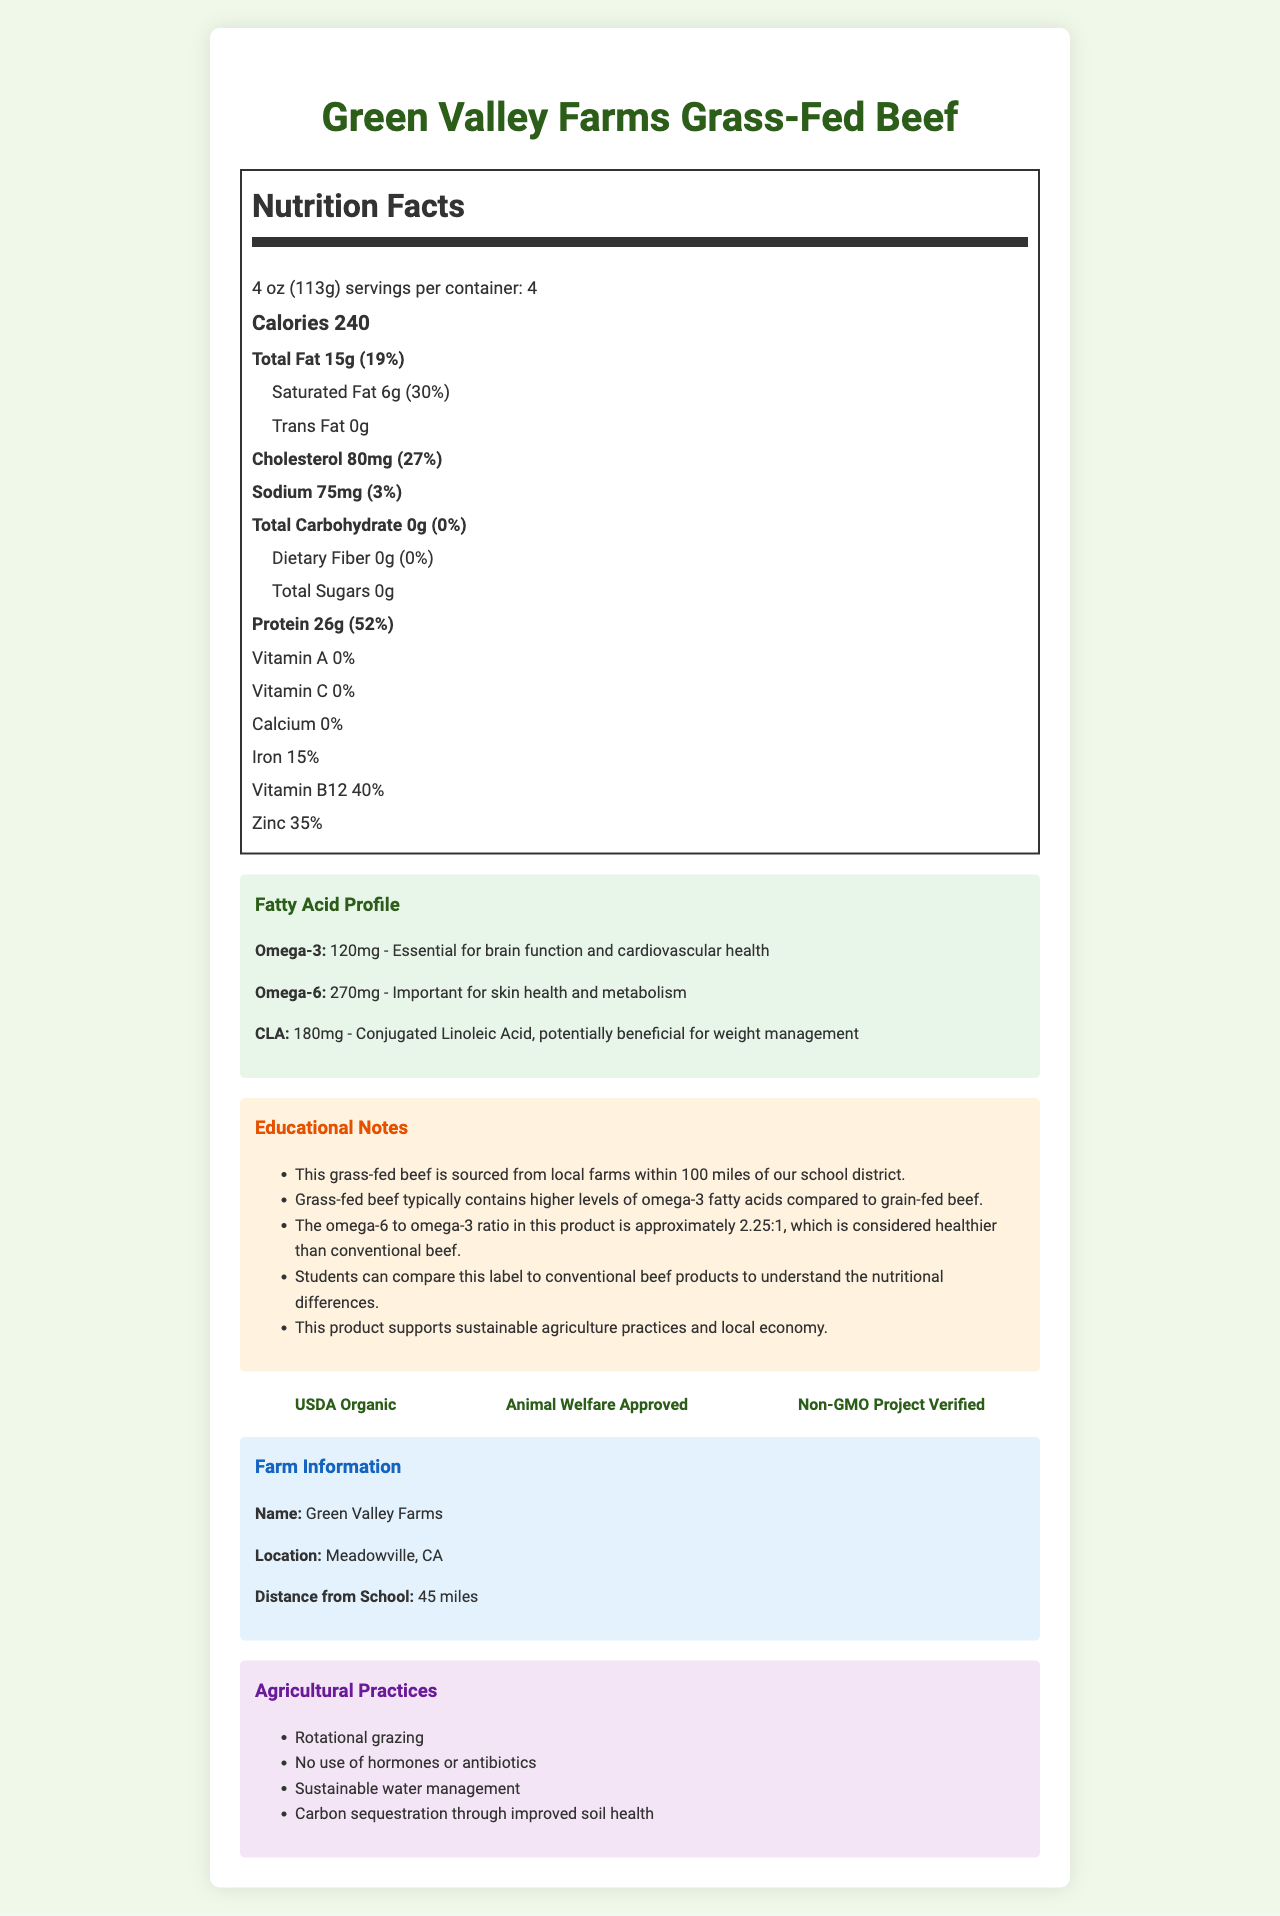which product is described in the document? The product name is stated at the top of the document as "Green Valley Farms Grass-Fed Beef".
Answer: Green Valley Farms Grass-Fed Beef what is the serving size? The serving size is mentioned near the top of the Nutrition Facts section as "4 oz (113g)".
Answer: 4 oz (113g) how many calories are in one serving of this beef product? The calories per serving are listed in the large bold text: "Calories 240".
Answer: 240 calories what is the amount of protein per serving, and what percentage of the daily value does it represent? The amount of protein per serving is 26g, and it represents 52% of the daily value, as listed in the Nutrition Facts section.
Answer: 26g, 52% how much omega-3 fatty acid is in one serving, and why is it important? The omega-3 fatty acid content is 120mg, and it is essential for brain function and cardiovascular health, as detailed in the Fatty Acid Profile section.
Answer: 120mg, Essential for brain function and cardiovascular health what is the educational note related to omega-3 fatty acids in grass-fed beef? This note emphasizes the nutritional superiority of grass-fed beef regarding omega-3 fatty acids.
Answer: Grass-fed beef typically contains higher levels of omega-3 fatty acids compared to grain-fed beef. how many certifications does this product have, and can you name them? The product has three certifications, listed in the certifications section.
Answer: Three certifications: USDA Organic, Animal Welfare Approved, Non-GMO Project Verified what are the key agricultural practices used by Green Valley Farms? These practices are highlighted in the Agricultural Practices section.
Answer: Rotational grazing, No use of hormones or antibiotics, Sustainable water management, Carbon sequestration through improved soil health how far is Green Valley Farms from the school? The distance from the school is stated in the Farm Information section.
Answer: 45 miles what is the ratio of omega-6 to omega-3 fatty acids in this product? A. 1:1 B. 2.25:1 C. 3:1 D. 4:1 The omega-6 to omega-3 ratio is given as approximately 2.25:1 in the Educational Notes section.
Answer: B. 2.25:1 which nutrient has the highest daily value percentage per serving? A. Vitamin A B. Protein C. Iron D. Cholesterol Protein has the highest daily value percentage per serving at 52%, as mentioned in the Nutrition Facts section.
Answer: B. Protein is this grass-fed beef product a good source of vitamin C? The document states that the daily value for vitamin C is 0%, indicating that it is not a significant source of this nutrient.
Answer: No summarize the main points of the document. The summary encompasses the nutrition facts (e.g., calories, fats, proteins), the importance of fatty acids, certifications, and educational notes about sustainable farming practices and local sourcing.
Answer: The document describes the nutrition facts, certifications, and farming practices for Green Valley Farms Grass-Fed Beef. It highlights the product's health benefits, including higher levels of omega-3 fatty acids, and supports sustainable agriculture. The beef is locally sourced and certified as organic, animal welfare approved, and non-GMO. what is the exact fatty acid profile of this product? The document provides the amounts and descriptions of omega-3, omega-6, and CLA, but does not specify the entire complex profile of all fatty acids present.
Answer: Not enough information 